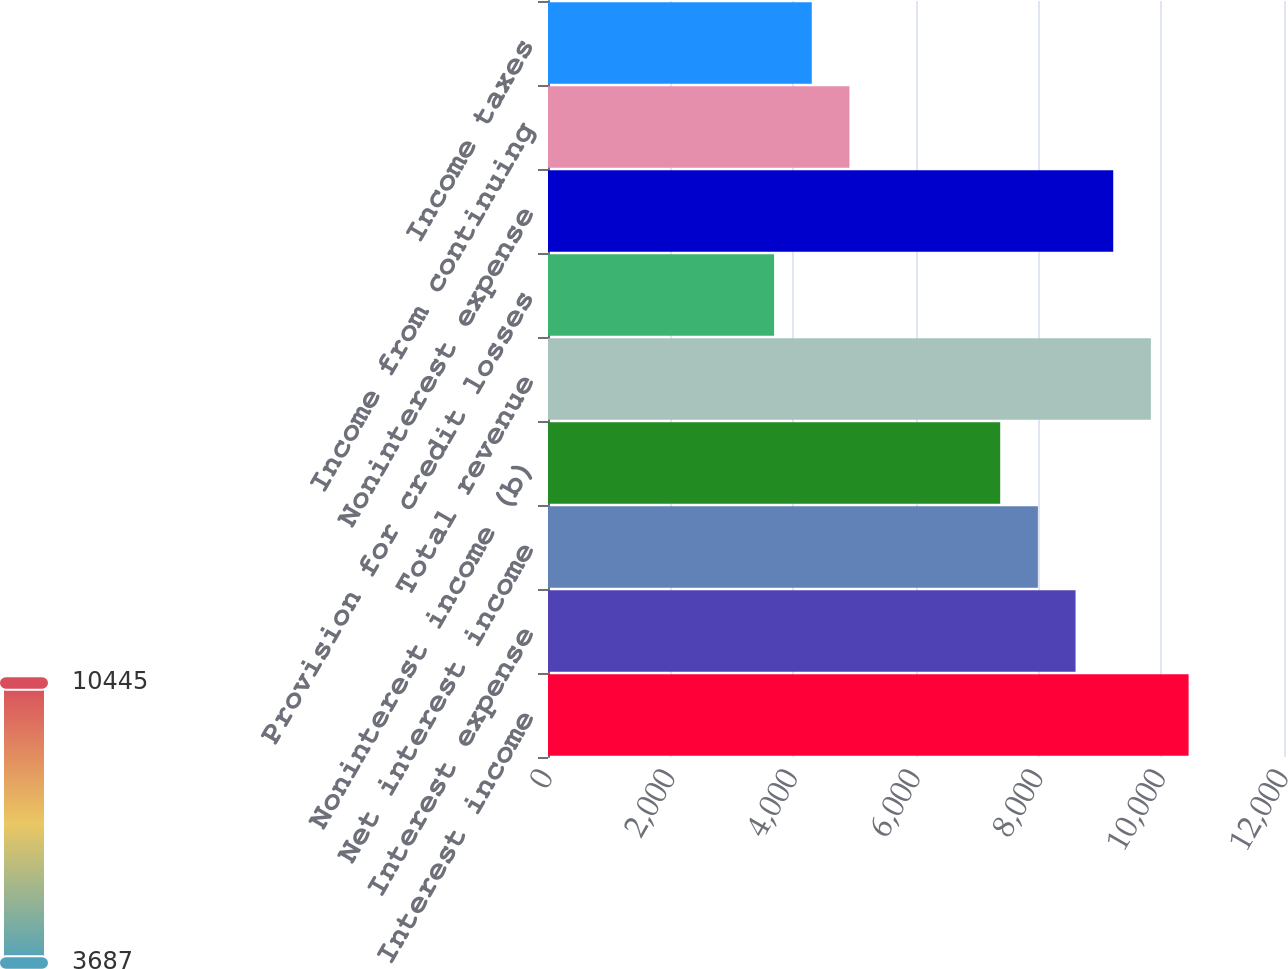Convert chart to OTSL. <chart><loc_0><loc_0><loc_500><loc_500><bar_chart><fcel>Interest income<fcel>Interest expense<fcel>Net interest income<fcel>Noninterest income (b)<fcel>Total revenue<fcel>Provision for credit losses<fcel>Noninterest expense<fcel>Income from continuing<fcel>Income taxes<nl><fcel>10444.5<fcel>8601.42<fcel>7987.06<fcel>7372.7<fcel>9830.14<fcel>3686.54<fcel>9215.78<fcel>4915.26<fcel>4300.9<nl></chart> 